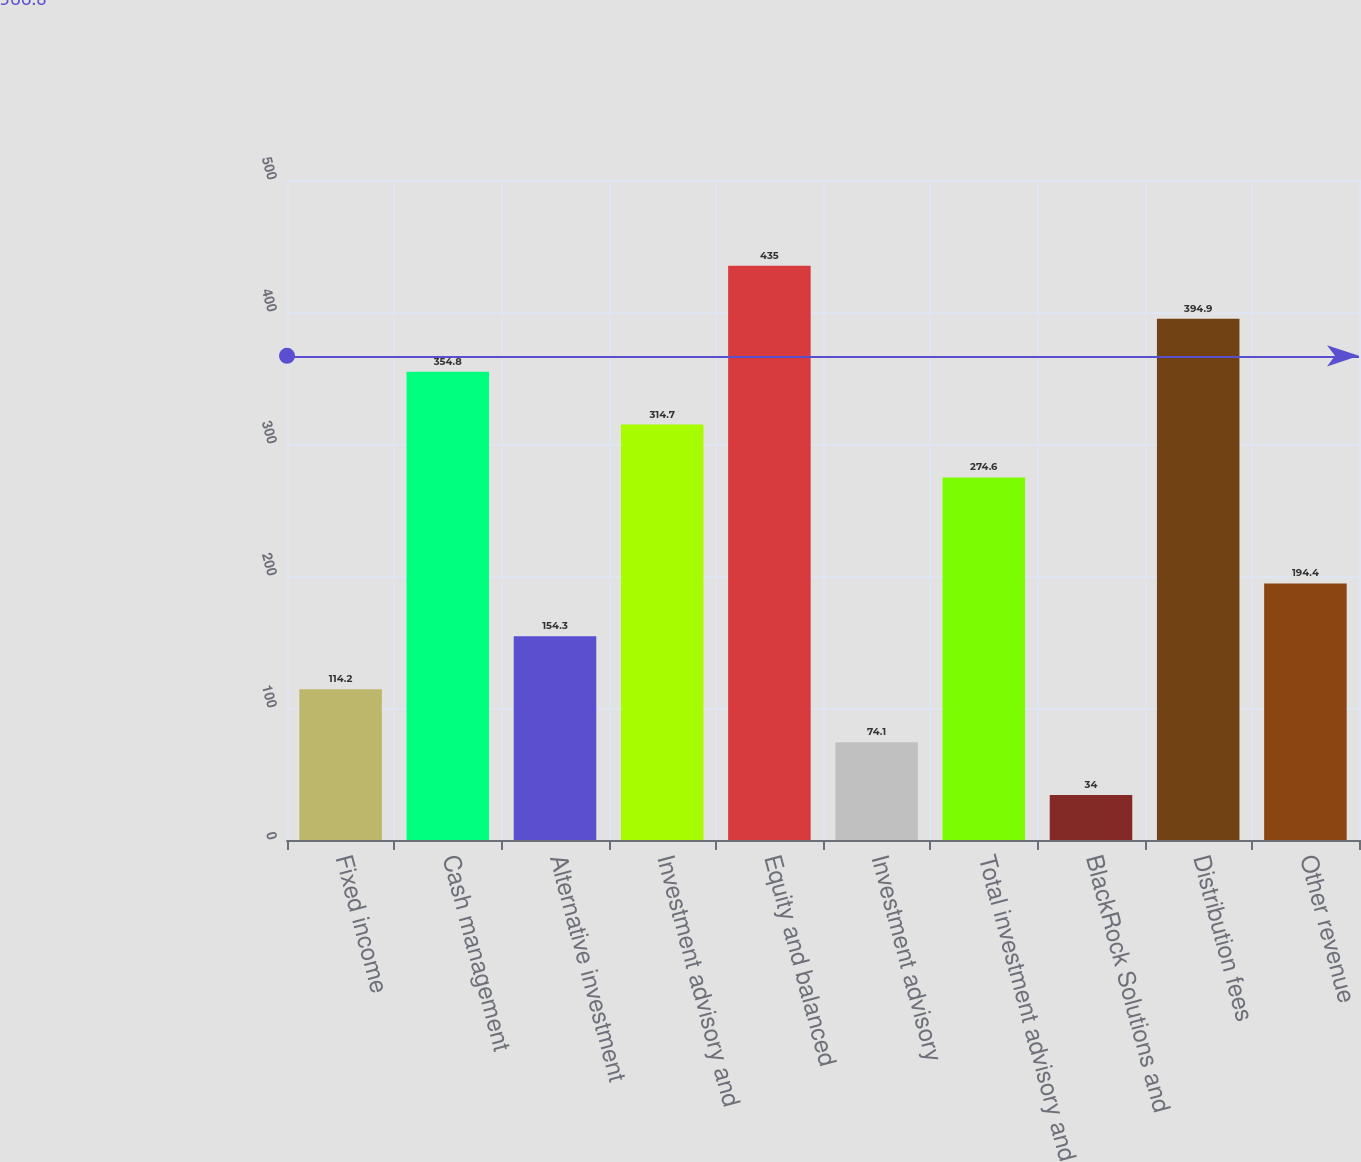Convert chart to OTSL. <chart><loc_0><loc_0><loc_500><loc_500><bar_chart><fcel>Fixed income<fcel>Cash management<fcel>Alternative investment<fcel>Investment advisory and<fcel>Equity and balanced<fcel>Investment advisory<fcel>Total investment advisory and<fcel>BlackRock Solutions and<fcel>Distribution fees<fcel>Other revenue<nl><fcel>114.2<fcel>354.8<fcel>154.3<fcel>314.7<fcel>435<fcel>74.1<fcel>274.6<fcel>34<fcel>394.9<fcel>194.4<nl></chart> 